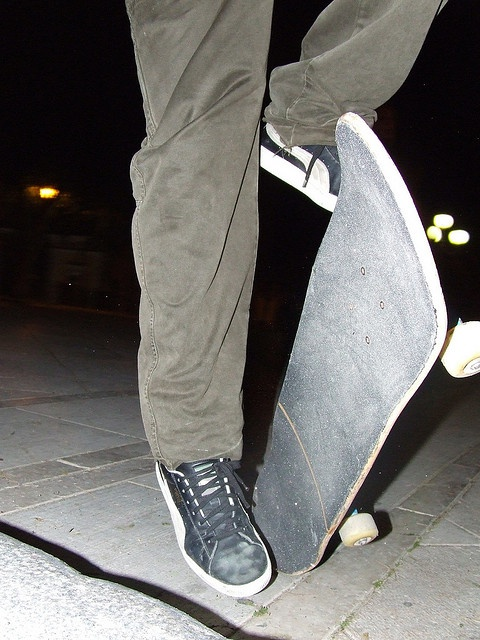Describe the objects in this image and their specific colors. I can see people in black, darkgray, and gray tones and skateboard in black, lightgray, darkgray, and gray tones in this image. 